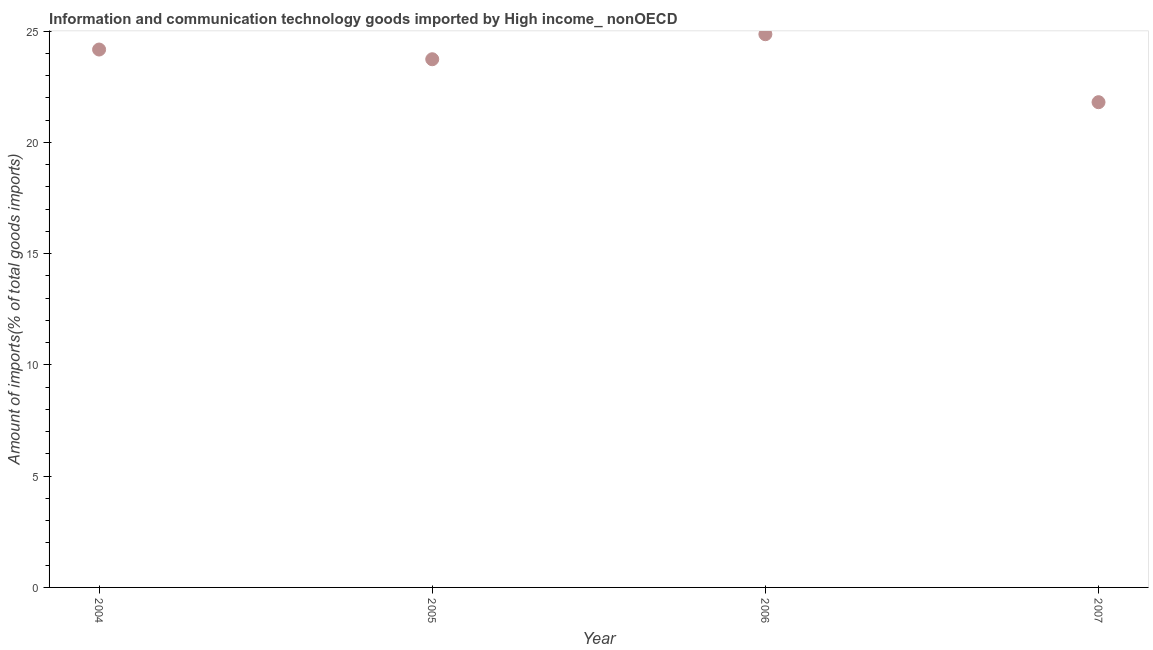What is the amount of ict goods imports in 2004?
Keep it short and to the point. 24.17. Across all years, what is the maximum amount of ict goods imports?
Provide a succinct answer. 24.86. Across all years, what is the minimum amount of ict goods imports?
Provide a succinct answer. 21.8. In which year was the amount of ict goods imports maximum?
Offer a terse response. 2006. In which year was the amount of ict goods imports minimum?
Offer a very short reply. 2007. What is the sum of the amount of ict goods imports?
Make the answer very short. 94.56. What is the difference between the amount of ict goods imports in 2006 and 2007?
Provide a short and direct response. 3.05. What is the average amount of ict goods imports per year?
Your answer should be compact. 23.64. What is the median amount of ict goods imports?
Your response must be concise. 23.95. In how many years, is the amount of ict goods imports greater than 16 %?
Give a very brief answer. 4. What is the ratio of the amount of ict goods imports in 2006 to that in 2007?
Ensure brevity in your answer.  1.14. Is the difference between the amount of ict goods imports in 2004 and 2006 greater than the difference between any two years?
Offer a terse response. No. What is the difference between the highest and the second highest amount of ict goods imports?
Offer a very short reply. 0.69. Is the sum of the amount of ict goods imports in 2004 and 2007 greater than the maximum amount of ict goods imports across all years?
Your answer should be compact. Yes. What is the difference between the highest and the lowest amount of ict goods imports?
Ensure brevity in your answer.  3.05. In how many years, is the amount of ict goods imports greater than the average amount of ict goods imports taken over all years?
Make the answer very short. 3. Does the graph contain any zero values?
Offer a very short reply. No. What is the title of the graph?
Your response must be concise. Information and communication technology goods imported by High income_ nonOECD. What is the label or title of the Y-axis?
Ensure brevity in your answer.  Amount of imports(% of total goods imports). What is the Amount of imports(% of total goods imports) in 2004?
Give a very brief answer. 24.17. What is the Amount of imports(% of total goods imports) in 2005?
Your answer should be very brief. 23.73. What is the Amount of imports(% of total goods imports) in 2006?
Give a very brief answer. 24.86. What is the Amount of imports(% of total goods imports) in 2007?
Ensure brevity in your answer.  21.8. What is the difference between the Amount of imports(% of total goods imports) in 2004 and 2005?
Make the answer very short. 0.44. What is the difference between the Amount of imports(% of total goods imports) in 2004 and 2006?
Give a very brief answer. -0.69. What is the difference between the Amount of imports(% of total goods imports) in 2004 and 2007?
Your answer should be very brief. 2.37. What is the difference between the Amount of imports(% of total goods imports) in 2005 and 2006?
Offer a terse response. -1.12. What is the difference between the Amount of imports(% of total goods imports) in 2005 and 2007?
Make the answer very short. 1.93. What is the difference between the Amount of imports(% of total goods imports) in 2006 and 2007?
Offer a very short reply. 3.05. What is the ratio of the Amount of imports(% of total goods imports) in 2004 to that in 2006?
Offer a very short reply. 0.97. What is the ratio of the Amount of imports(% of total goods imports) in 2004 to that in 2007?
Keep it short and to the point. 1.11. What is the ratio of the Amount of imports(% of total goods imports) in 2005 to that in 2006?
Provide a short and direct response. 0.95. What is the ratio of the Amount of imports(% of total goods imports) in 2005 to that in 2007?
Give a very brief answer. 1.09. What is the ratio of the Amount of imports(% of total goods imports) in 2006 to that in 2007?
Keep it short and to the point. 1.14. 